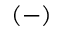<formula> <loc_0><loc_0><loc_500><loc_500>( - )</formula> 